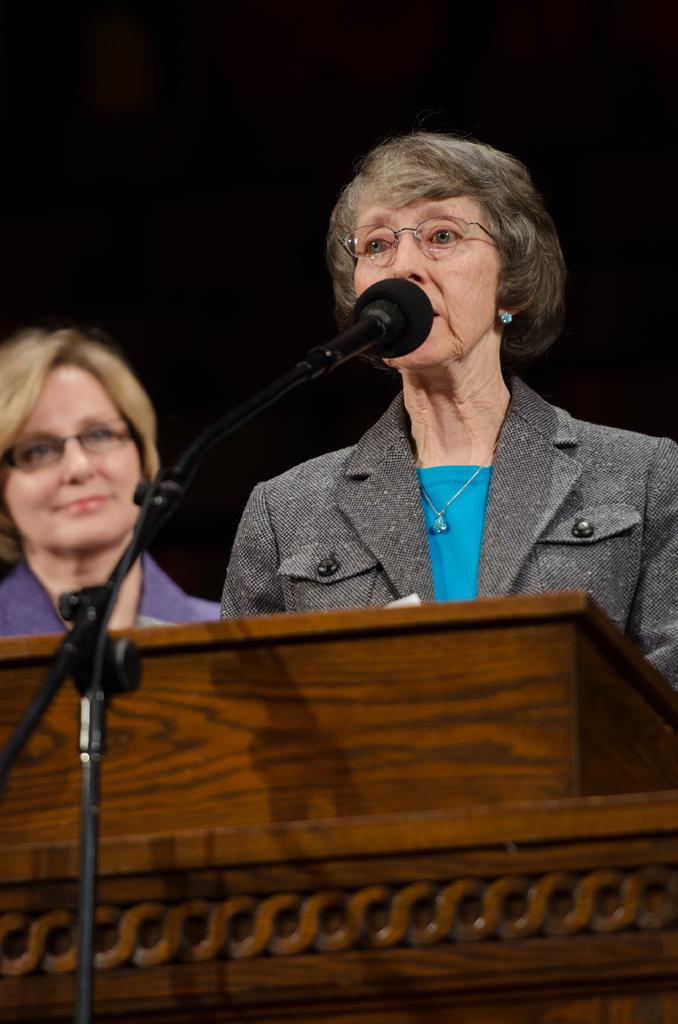How many people are in the image? There are two ladies in the image. What object can be seen in front of the ladies? There is a podium in the image. What device is present for amplifying sound? There is a microphone in the image. What type of material is present in the image for connecting devices? There are wires in the image. What can be observed about the lighting conditions in the image? The background of the image is dark. What type of creature is making a request from the podium in the image? There is no creature present in the image; it features two ladies and a podium. What thing is being requested by the creature in the image? There is no creature or request present in the image. 